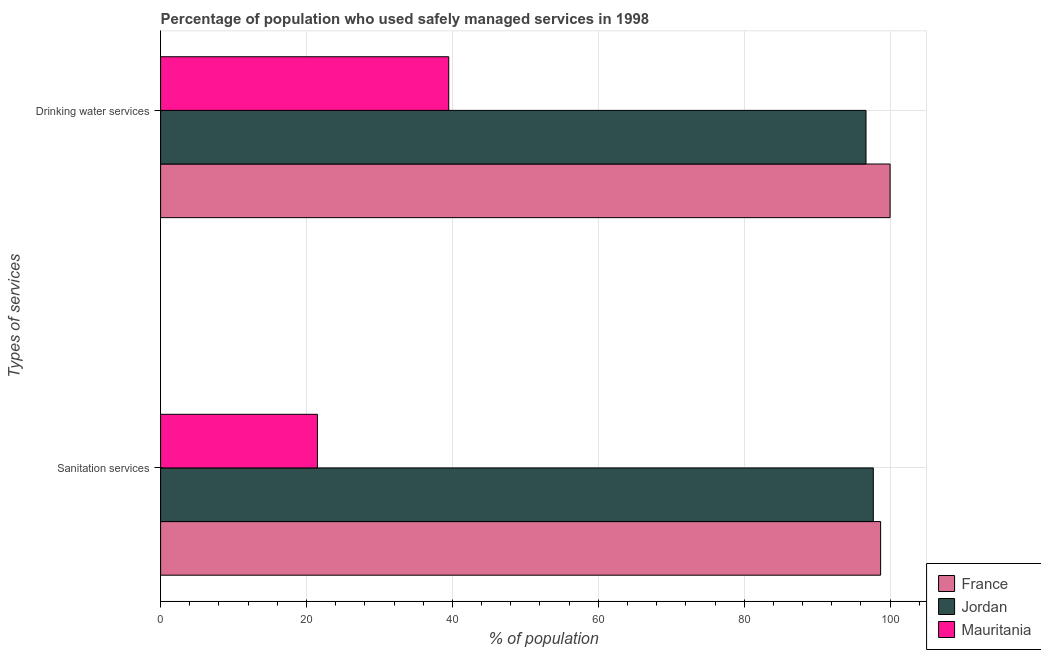How many groups of bars are there?
Your answer should be compact. 2. Are the number of bars on each tick of the Y-axis equal?
Your response must be concise. Yes. How many bars are there on the 2nd tick from the bottom?
Keep it short and to the point. 3. What is the label of the 1st group of bars from the top?
Make the answer very short. Drinking water services. What is the percentage of population who used sanitation services in France?
Offer a very short reply. 98.7. Across all countries, what is the maximum percentage of population who used drinking water services?
Keep it short and to the point. 100. In which country was the percentage of population who used sanitation services minimum?
Provide a short and direct response. Mauritania. What is the total percentage of population who used drinking water services in the graph?
Make the answer very short. 236.2. What is the difference between the percentage of population who used drinking water services in Jordan and that in Mauritania?
Your answer should be very brief. 57.2. What is the difference between the percentage of population who used sanitation services in France and the percentage of population who used drinking water services in Mauritania?
Offer a terse response. 59.2. What is the average percentage of population who used sanitation services per country?
Offer a very short reply. 72.63. What is the difference between the percentage of population who used drinking water services and percentage of population who used sanitation services in France?
Give a very brief answer. 1.3. What is the ratio of the percentage of population who used sanitation services in France to that in Jordan?
Your answer should be compact. 1.01. Is the percentage of population who used drinking water services in France less than that in Jordan?
Keep it short and to the point. No. In how many countries, is the percentage of population who used drinking water services greater than the average percentage of population who used drinking water services taken over all countries?
Ensure brevity in your answer.  2. What does the 2nd bar from the top in Sanitation services represents?
Your response must be concise. Jordan. What does the 1st bar from the bottom in Sanitation services represents?
Your answer should be compact. France. Are the values on the major ticks of X-axis written in scientific E-notation?
Make the answer very short. No. Does the graph contain grids?
Your answer should be compact. Yes. How are the legend labels stacked?
Make the answer very short. Vertical. What is the title of the graph?
Provide a short and direct response. Percentage of population who used safely managed services in 1998. Does "Sub-Saharan Africa (all income levels)" appear as one of the legend labels in the graph?
Give a very brief answer. No. What is the label or title of the X-axis?
Provide a succinct answer. % of population. What is the label or title of the Y-axis?
Offer a terse response. Types of services. What is the % of population of France in Sanitation services?
Ensure brevity in your answer.  98.7. What is the % of population in Jordan in Sanitation services?
Provide a short and direct response. 97.7. What is the % of population of Jordan in Drinking water services?
Your answer should be very brief. 96.7. What is the % of population in Mauritania in Drinking water services?
Your response must be concise. 39.5. Across all Types of services, what is the maximum % of population in Jordan?
Offer a very short reply. 97.7. Across all Types of services, what is the maximum % of population of Mauritania?
Offer a very short reply. 39.5. Across all Types of services, what is the minimum % of population in France?
Provide a succinct answer. 98.7. Across all Types of services, what is the minimum % of population of Jordan?
Make the answer very short. 96.7. Across all Types of services, what is the minimum % of population in Mauritania?
Provide a succinct answer. 21.5. What is the total % of population of France in the graph?
Make the answer very short. 198.7. What is the total % of population in Jordan in the graph?
Your answer should be compact. 194.4. What is the difference between the % of population in France in Sanitation services and that in Drinking water services?
Offer a terse response. -1.3. What is the difference between the % of population of Jordan in Sanitation services and that in Drinking water services?
Offer a terse response. 1. What is the difference between the % of population of Mauritania in Sanitation services and that in Drinking water services?
Ensure brevity in your answer.  -18. What is the difference between the % of population in France in Sanitation services and the % of population in Mauritania in Drinking water services?
Your answer should be compact. 59.2. What is the difference between the % of population of Jordan in Sanitation services and the % of population of Mauritania in Drinking water services?
Ensure brevity in your answer.  58.2. What is the average % of population in France per Types of services?
Your answer should be compact. 99.35. What is the average % of population of Jordan per Types of services?
Provide a short and direct response. 97.2. What is the average % of population of Mauritania per Types of services?
Make the answer very short. 30.5. What is the difference between the % of population in France and % of population in Jordan in Sanitation services?
Your answer should be compact. 1. What is the difference between the % of population in France and % of population in Mauritania in Sanitation services?
Offer a terse response. 77.2. What is the difference between the % of population in Jordan and % of population in Mauritania in Sanitation services?
Provide a succinct answer. 76.2. What is the difference between the % of population of France and % of population of Mauritania in Drinking water services?
Make the answer very short. 60.5. What is the difference between the % of population of Jordan and % of population of Mauritania in Drinking water services?
Your answer should be compact. 57.2. What is the ratio of the % of population of France in Sanitation services to that in Drinking water services?
Offer a terse response. 0.99. What is the ratio of the % of population of Jordan in Sanitation services to that in Drinking water services?
Provide a succinct answer. 1.01. What is the ratio of the % of population in Mauritania in Sanitation services to that in Drinking water services?
Your answer should be compact. 0.54. What is the difference between the highest and the second highest % of population of Mauritania?
Your answer should be compact. 18. What is the difference between the highest and the lowest % of population in France?
Ensure brevity in your answer.  1.3. 